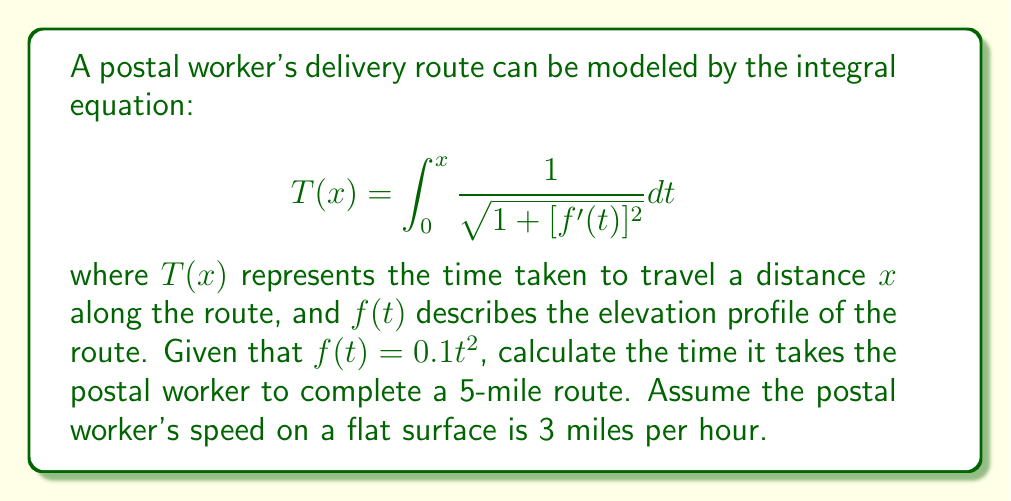Help me with this question. To solve this problem, we'll follow these steps:

1) First, we need to find $f'(t)$:
   $$f'(t) = 0.2t$$

2) Substitute this into the integral equation:
   $$T(x) = \int_0^x \frac{1}{\sqrt{1 + (0.2t)^2}} dt$$

3) Simplify the integrand:
   $$T(x) = \int_0^x \frac{1}{\sqrt{1 + 0.04t^2}} dt$$

4) This integral doesn't have an elementary antiderivative. We need to use a substitution:
   Let $u = 0.2t$, then $du = 0.2dt$ or $dt = 5du$
   When $t = 0$, $u = 0$; when $t = x$, $u = 0.2x$

5) Rewrite the integral:
   $$T(x) = 5\int_0^{0.2x} \frac{1}{\sqrt{1 + u^2}} du$$

6) This is the inverse hyperbolic sine function:
   $$T(x) = 5 \cdot \text{arcsinh}(0.2x)$$

7) For a 5-mile route, we need to calculate $T(5)$:
   $$T(5) = 5 \cdot \text{arcsinh}(1) \approx 5 \cdot 0.8814 = 4.407$$

8) This time is in hours. To convert to minutes:
   $$4.407 \text{ hours} = 4.407 \cdot 60 \approx 264.42 \text{ minutes}$$

Therefore, it takes the postal worker approximately 264.42 minutes to complete the 5-mile route.
Answer: 264.42 minutes 